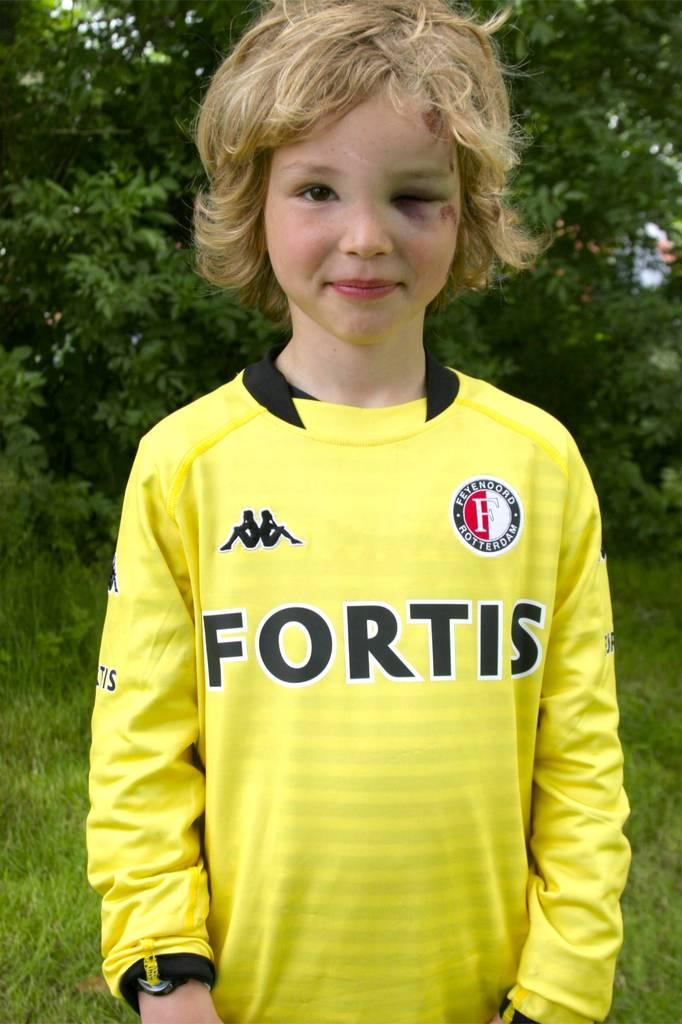Provide a one-sentence caption for the provided image. A blonde child wearing a yellow FORTIS shirt has a black left eye. 